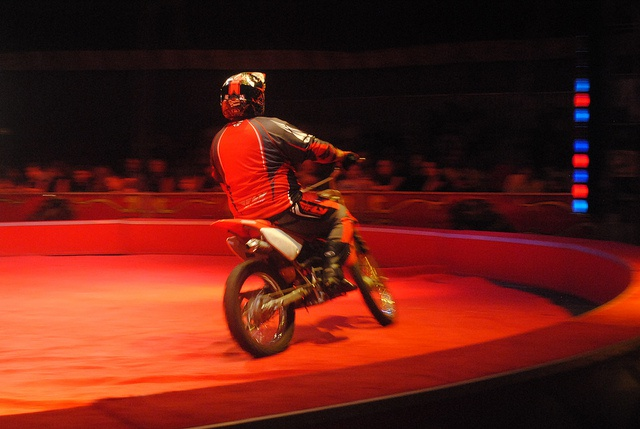Describe the objects in this image and their specific colors. I can see motorcycle in black, maroon, and brown tones and people in black, red, maroon, and brown tones in this image. 